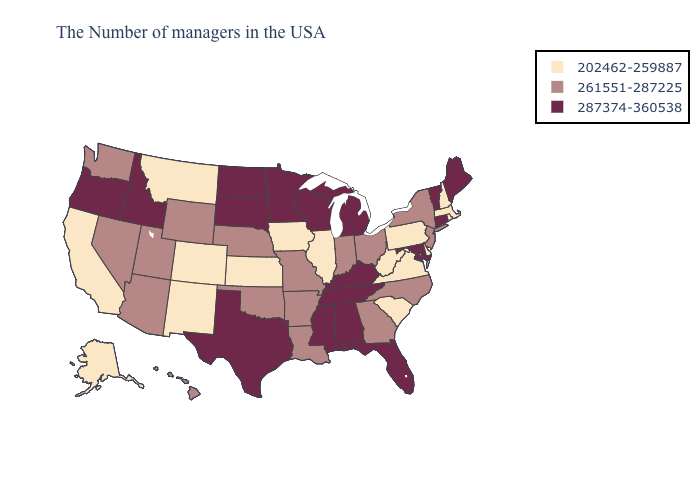What is the value of California?
Give a very brief answer. 202462-259887. Does Massachusetts have the highest value in the USA?
Answer briefly. No. What is the lowest value in the USA?
Quick response, please. 202462-259887. Does Minnesota have the highest value in the USA?
Short answer required. Yes. Name the states that have a value in the range 287374-360538?
Give a very brief answer. Maine, Vermont, Connecticut, Maryland, Florida, Michigan, Kentucky, Alabama, Tennessee, Wisconsin, Mississippi, Minnesota, Texas, South Dakota, North Dakota, Idaho, Oregon. Name the states that have a value in the range 261551-287225?
Answer briefly. New York, New Jersey, North Carolina, Ohio, Georgia, Indiana, Louisiana, Missouri, Arkansas, Nebraska, Oklahoma, Wyoming, Utah, Arizona, Nevada, Washington, Hawaii. What is the value of New York?
Concise answer only. 261551-287225. What is the lowest value in the West?
Give a very brief answer. 202462-259887. What is the value of Delaware?
Concise answer only. 202462-259887. What is the lowest value in the USA?
Answer briefly. 202462-259887. What is the lowest value in states that border Illinois?
Quick response, please. 202462-259887. Which states have the highest value in the USA?
Write a very short answer. Maine, Vermont, Connecticut, Maryland, Florida, Michigan, Kentucky, Alabama, Tennessee, Wisconsin, Mississippi, Minnesota, Texas, South Dakota, North Dakota, Idaho, Oregon. Name the states that have a value in the range 202462-259887?
Be succinct. Massachusetts, Rhode Island, New Hampshire, Delaware, Pennsylvania, Virginia, South Carolina, West Virginia, Illinois, Iowa, Kansas, Colorado, New Mexico, Montana, California, Alaska. What is the highest value in the MidWest ?
Write a very short answer. 287374-360538. 